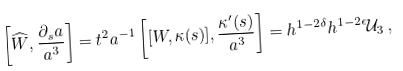Convert formula to latex. <formula><loc_0><loc_0><loc_500><loc_500>\left [ \widehat { W } , \frac { \partial _ { s } a } { a ^ { 3 } } \right ] = t ^ { 2 } a ^ { - 1 } \left [ [ W , \kappa ( s ) ] , \frac { \kappa ^ { \prime } ( s ) } { a ^ { 3 } } \right ] = h ^ { 1 - 2 \delta } h ^ { 1 - 2 \epsilon } { \mathcal { U } } _ { 3 } \, ,</formula> 